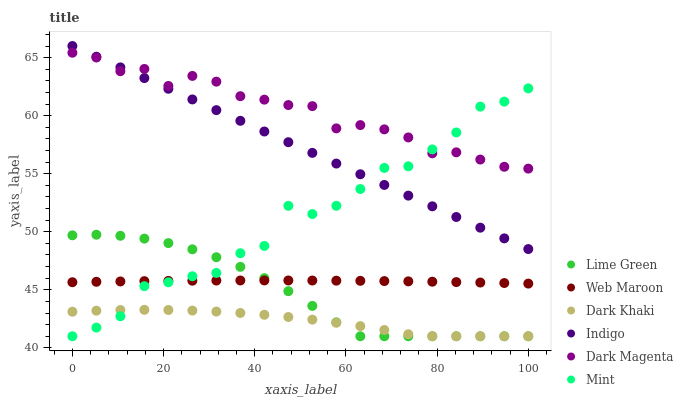Does Dark Khaki have the minimum area under the curve?
Answer yes or no. Yes. Does Dark Magenta have the maximum area under the curve?
Answer yes or no. Yes. Does Lime Green have the minimum area under the curve?
Answer yes or no. No. Does Lime Green have the maximum area under the curve?
Answer yes or no. No. Is Indigo the smoothest?
Answer yes or no. Yes. Is Mint the roughest?
Answer yes or no. Yes. Is Dark Magenta the smoothest?
Answer yes or no. No. Is Dark Magenta the roughest?
Answer yes or no. No. Does Lime Green have the lowest value?
Answer yes or no. Yes. Does Dark Magenta have the lowest value?
Answer yes or no. No. Does Indigo have the highest value?
Answer yes or no. Yes. Does Dark Magenta have the highest value?
Answer yes or no. No. Is Dark Khaki less than Indigo?
Answer yes or no. Yes. Is Indigo greater than Web Maroon?
Answer yes or no. Yes. Does Lime Green intersect Dark Khaki?
Answer yes or no. Yes. Is Lime Green less than Dark Khaki?
Answer yes or no. No. Is Lime Green greater than Dark Khaki?
Answer yes or no. No. Does Dark Khaki intersect Indigo?
Answer yes or no. No. 